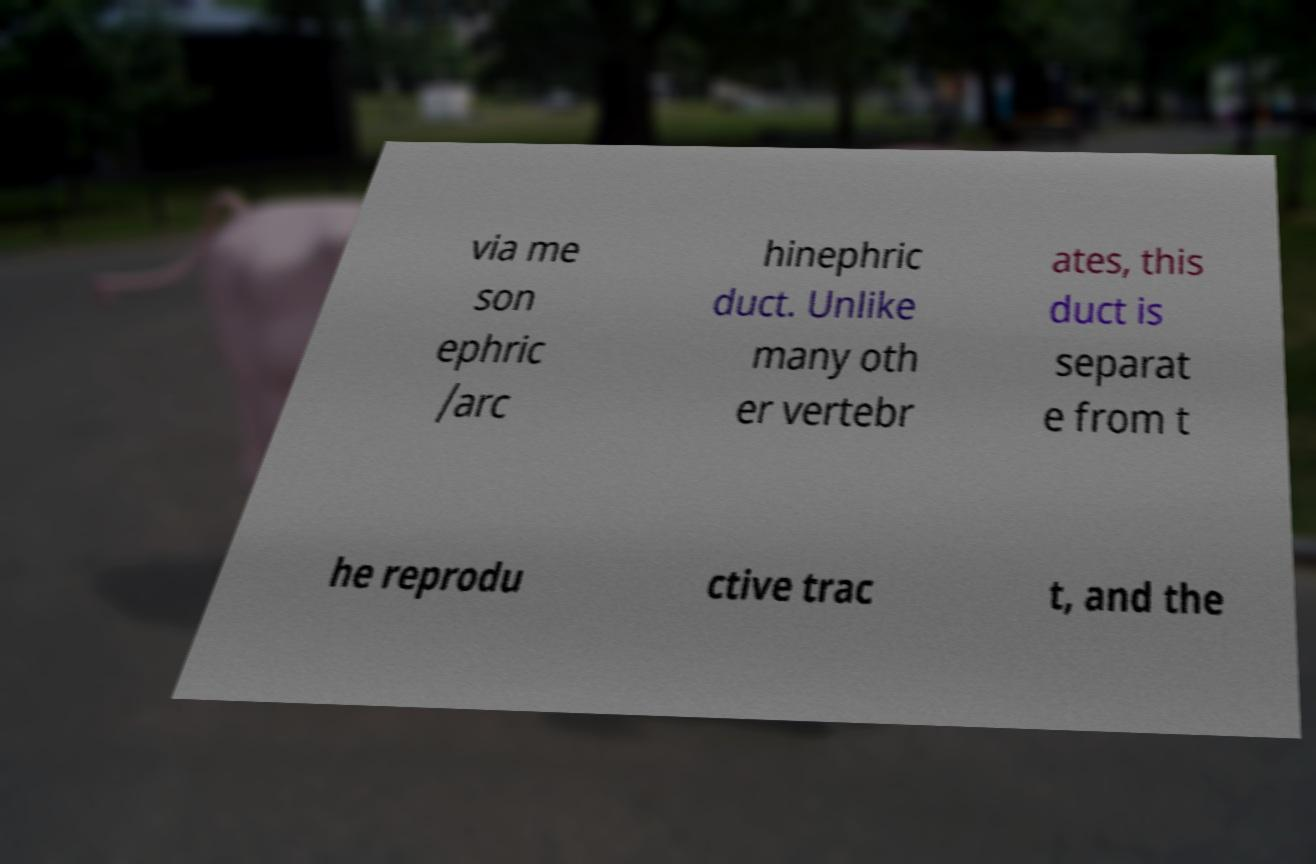Can you accurately transcribe the text from the provided image for me? via me son ephric /arc hinephric duct. Unlike many oth er vertebr ates, this duct is separat e from t he reprodu ctive trac t, and the 